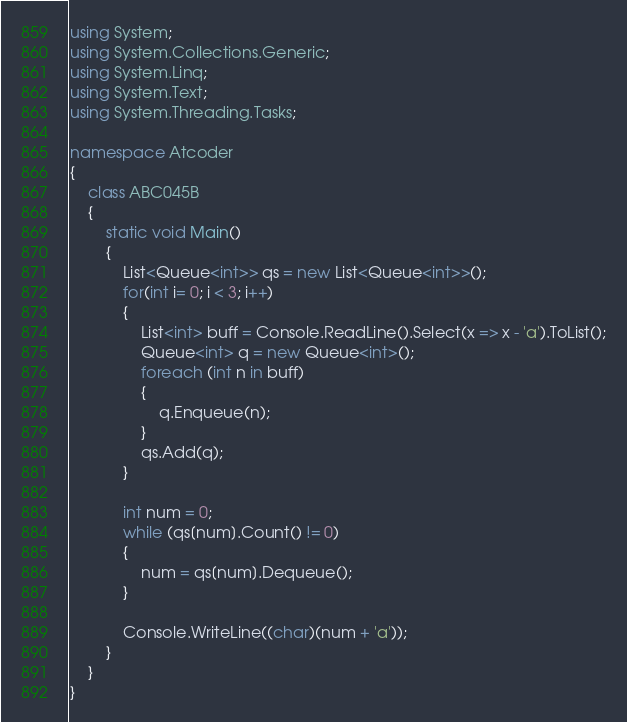<code> <loc_0><loc_0><loc_500><loc_500><_C#_>using System;
using System.Collections.Generic;
using System.Linq;
using System.Text;
using System.Threading.Tasks;

namespace Atcoder
{
	class ABC045B
	{
		static void Main()
		{
			List<Queue<int>> qs = new List<Queue<int>>();
			for(int i= 0; i < 3; i++)
			{
				List<int> buff = Console.ReadLine().Select(x => x - 'a').ToList();
				Queue<int> q = new Queue<int>();
				foreach (int n in buff)
				{
					q.Enqueue(n);
				}
				qs.Add(q);
			}

			int num = 0;
			while (qs[num].Count() != 0)
			{
				num = qs[num].Dequeue();
			}

			Console.WriteLine((char)(num + 'a'));
		}
	}
}
</code> 